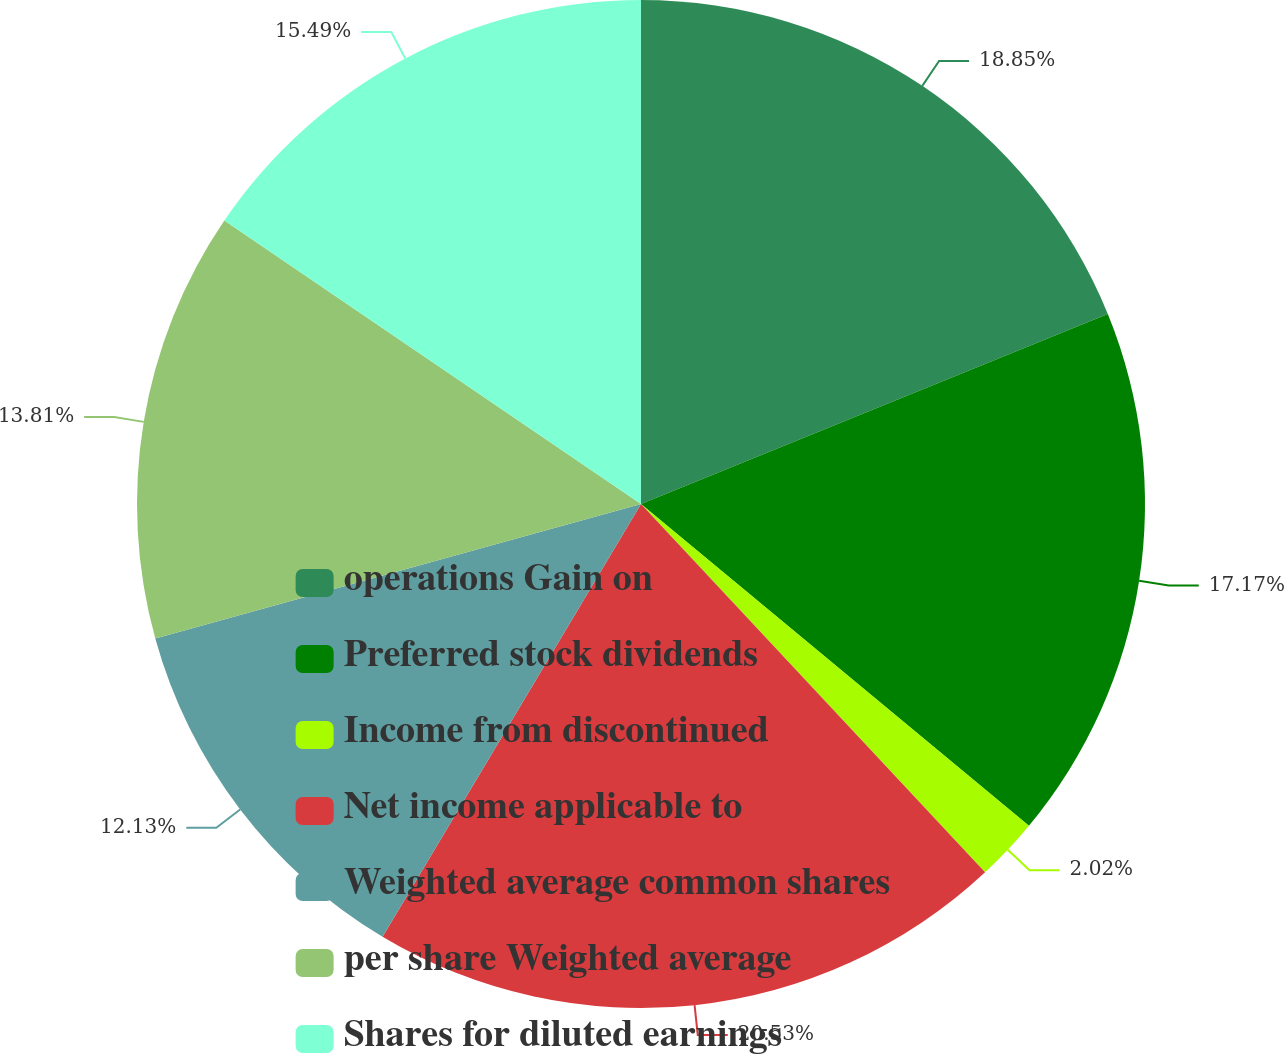<chart> <loc_0><loc_0><loc_500><loc_500><pie_chart><fcel>operations Gain on<fcel>Preferred stock dividends<fcel>Income from discontinued<fcel>Net income applicable to<fcel>Weighted average common shares<fcel>per share Weighted average<fcel>Shares for diluted earnings<nl><fcel>18.85%<fcel>17.17%<fcel>2.02%<fcel>20.53%<fcel>12.13%<fcel>13.81%<fcel>15.49%<nl></chart> 